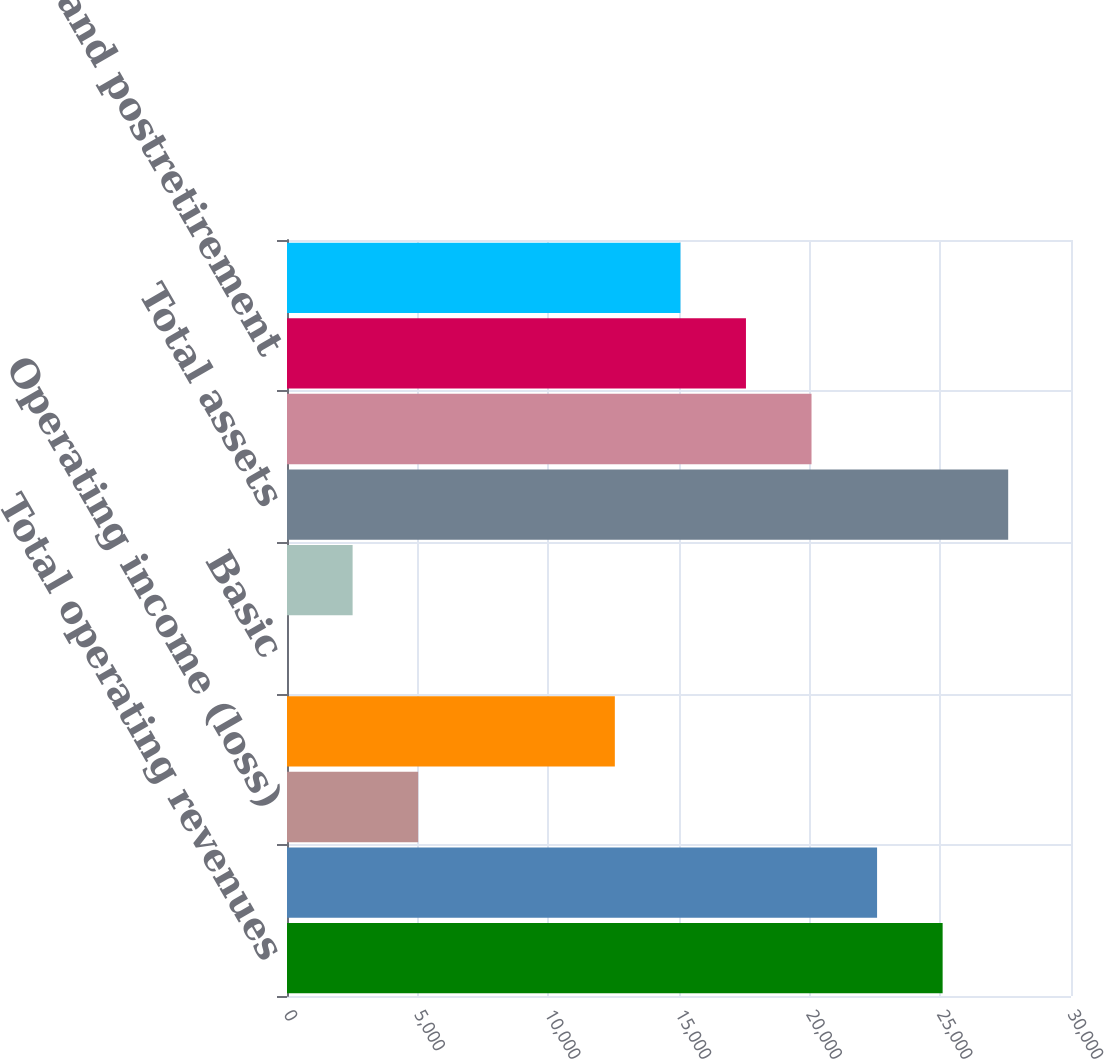<chart> <loc_0><loc_0><loc_500><loc_500><bar_chart><fcel>Total operating revenues<fcel>Total operating expenses<fcel>Operating income (loss)<fcel>Net income (loss)<fcel>Basic<fcel>Diluted<fcel>Total assets<fcel>Long-term debt and capital<fcel>Pension and postretirement<fcel>Stockholders' equity (deficit)<nl><fcel>25088<fcel>22579.4<fcel>5019.12<fcel>12545<fcel>1.9<fcel>2510.51<fcel>27596.6<fcel>20070.8<fcel>17562.2<fcel>15053.6<nl></chart> 